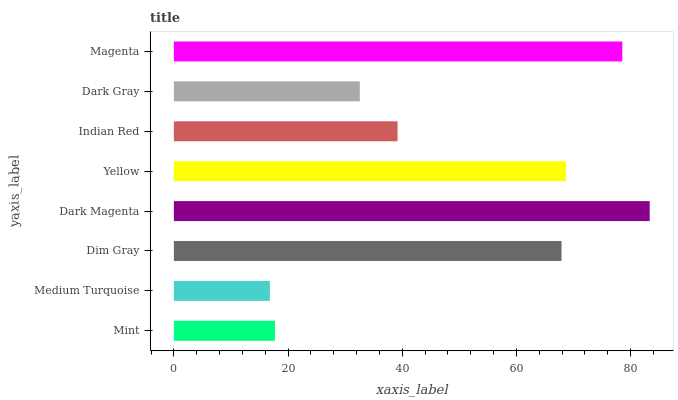Is Medium Turquoise the minimum?
Answer yes or no. Yes. Is Dark Magenta the maximum?
Answer yes or no. Yes. Is Dim Gray the minimum?
Answer yes or no. No. Is Dim Gray the maximum?
Answer yes or no. No. Is Dim Gray greater than Medium Turquoise?
Answer yes or no. Yes. Is Medium Turquoise less than Dim Gray?
Answer yes or no. Yes. Is Medium Turquoise greater than Dim Gray?
Answer yes or no. No. Is Dim Gray less than Medium Turquoise?
Answer yes or no. No. Is Dim Gray the high median?
Answer yes or no. Yes. Is Indian Red the low median?
Answer yes or no. Yes. Is Dark Magenta the high median?
Answer yes or no. No. Is Magenta the low median?
Answer yes or no. No. 